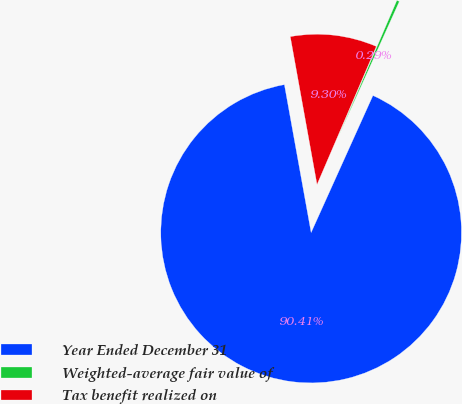Convert chart. <chart><loc_0><loc_0><loc_500><loc_500><pie_chart><fcel>Year Ended December 31<fcel>Weighted-average fair value of<fcel>Tax benefit realized on<nl><fcel>90.41%<fcel>0.29%<fcel>9.3%<nl></chart> 